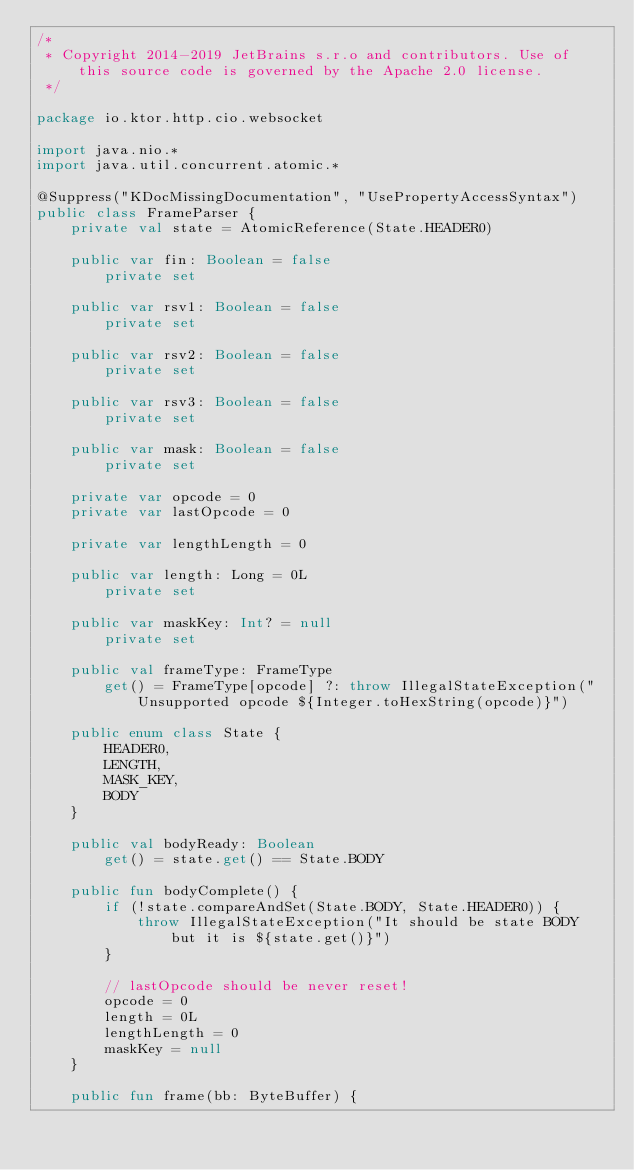<code> <loc_0><loc_0><loc_500><loc_500><_Kotlin_>/*
 * Copyright 2014-2019 JetBrains s.r.o and contributors. Use of this source code is governed by the Apache 2.0 license.
 */

package io.ktor.http.cio.websocket

import java.nio.*
import java.util.concurrent.atomic.*

@Suppress("KDocMissingDocumentation", "UsePropertyAccessSyntax")
public class FrameParser {
    private val state = AtomicReference(State.HEADER0)

    public var fin: Boolean = false
        private set

    public var rsv1: Boolean = false
        private set

    public var rsv2: Boolean = false
        private set

    public var rsv3: Boolean = false
        private set

    public var mask: Boolean = false
        private set

    private var opcode = 0
    private var lastOpcode = 0

    private var lengthLength = 0

    public var length: Long = 0L
        private set

    public var maskKey: Int? = null
        private set

    public val frameType: FrameType
        get() = FrameType[opcode] ?: throw IllegalStateException("Unsupported opcode ${Integer.toHexString(opcode)}")

    public enum class State {
        HEADER0,
        LENGTH,
        MASK_KEY,
        BODY
    }

    public val bodyReady: Boolean
        get() = state.get() == State.BODY

    public fun bodyComplete() {
        if (!state.compareAndSet(State.BODY, State.HEADER0)) {
            throw IllegalStateException("It should be state BODY but it is ${state.get()}")
        }

        // lastOpcode should be never reset!
        opcode = 0
        length = 0L
        lengthLength = 0
        maskKey = null
    }

    public fun frame(bb: ByteBuffer) {</code> 